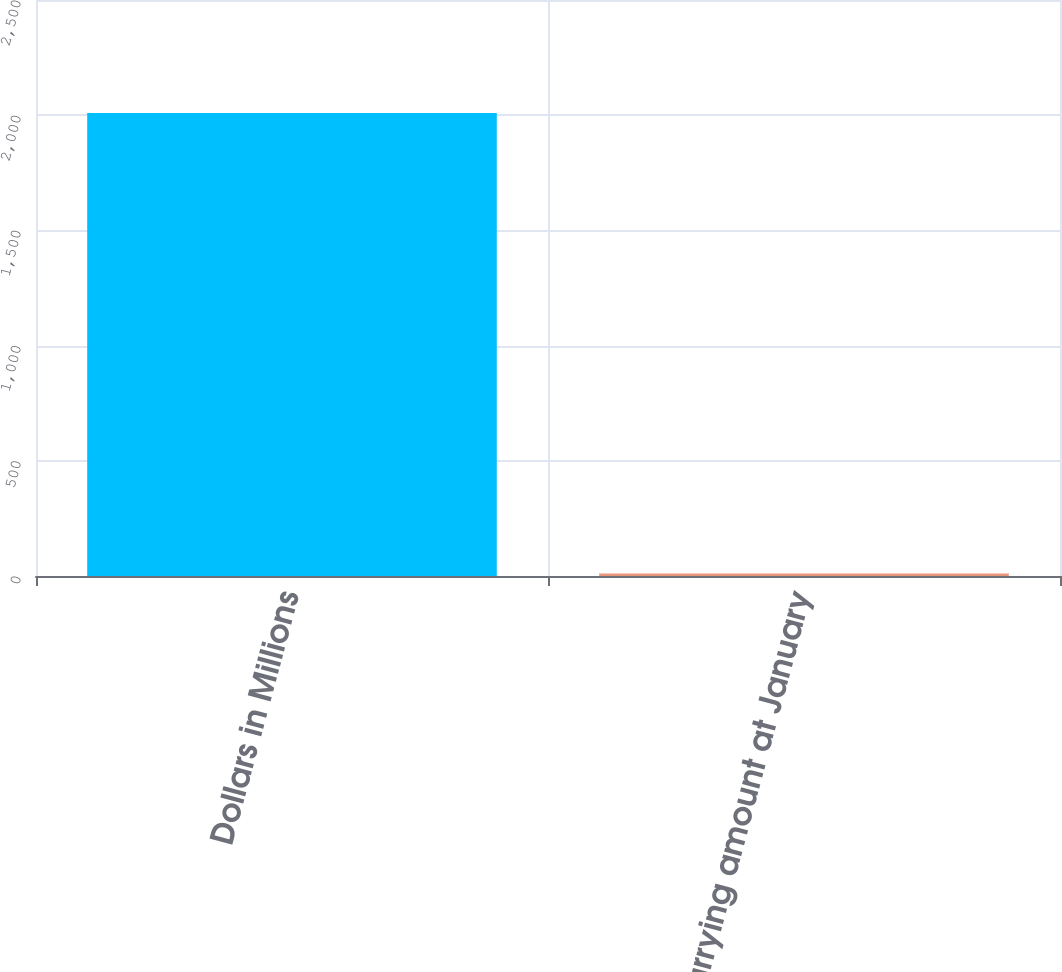Convert chart. <chart><loc_0><loc_0><loc_500><loc_500><bar_chart><fcel>Dollars in Millions<fcel>Net carrying amount at January<nl><fcel>2010<fcel>11<nl></chart> 